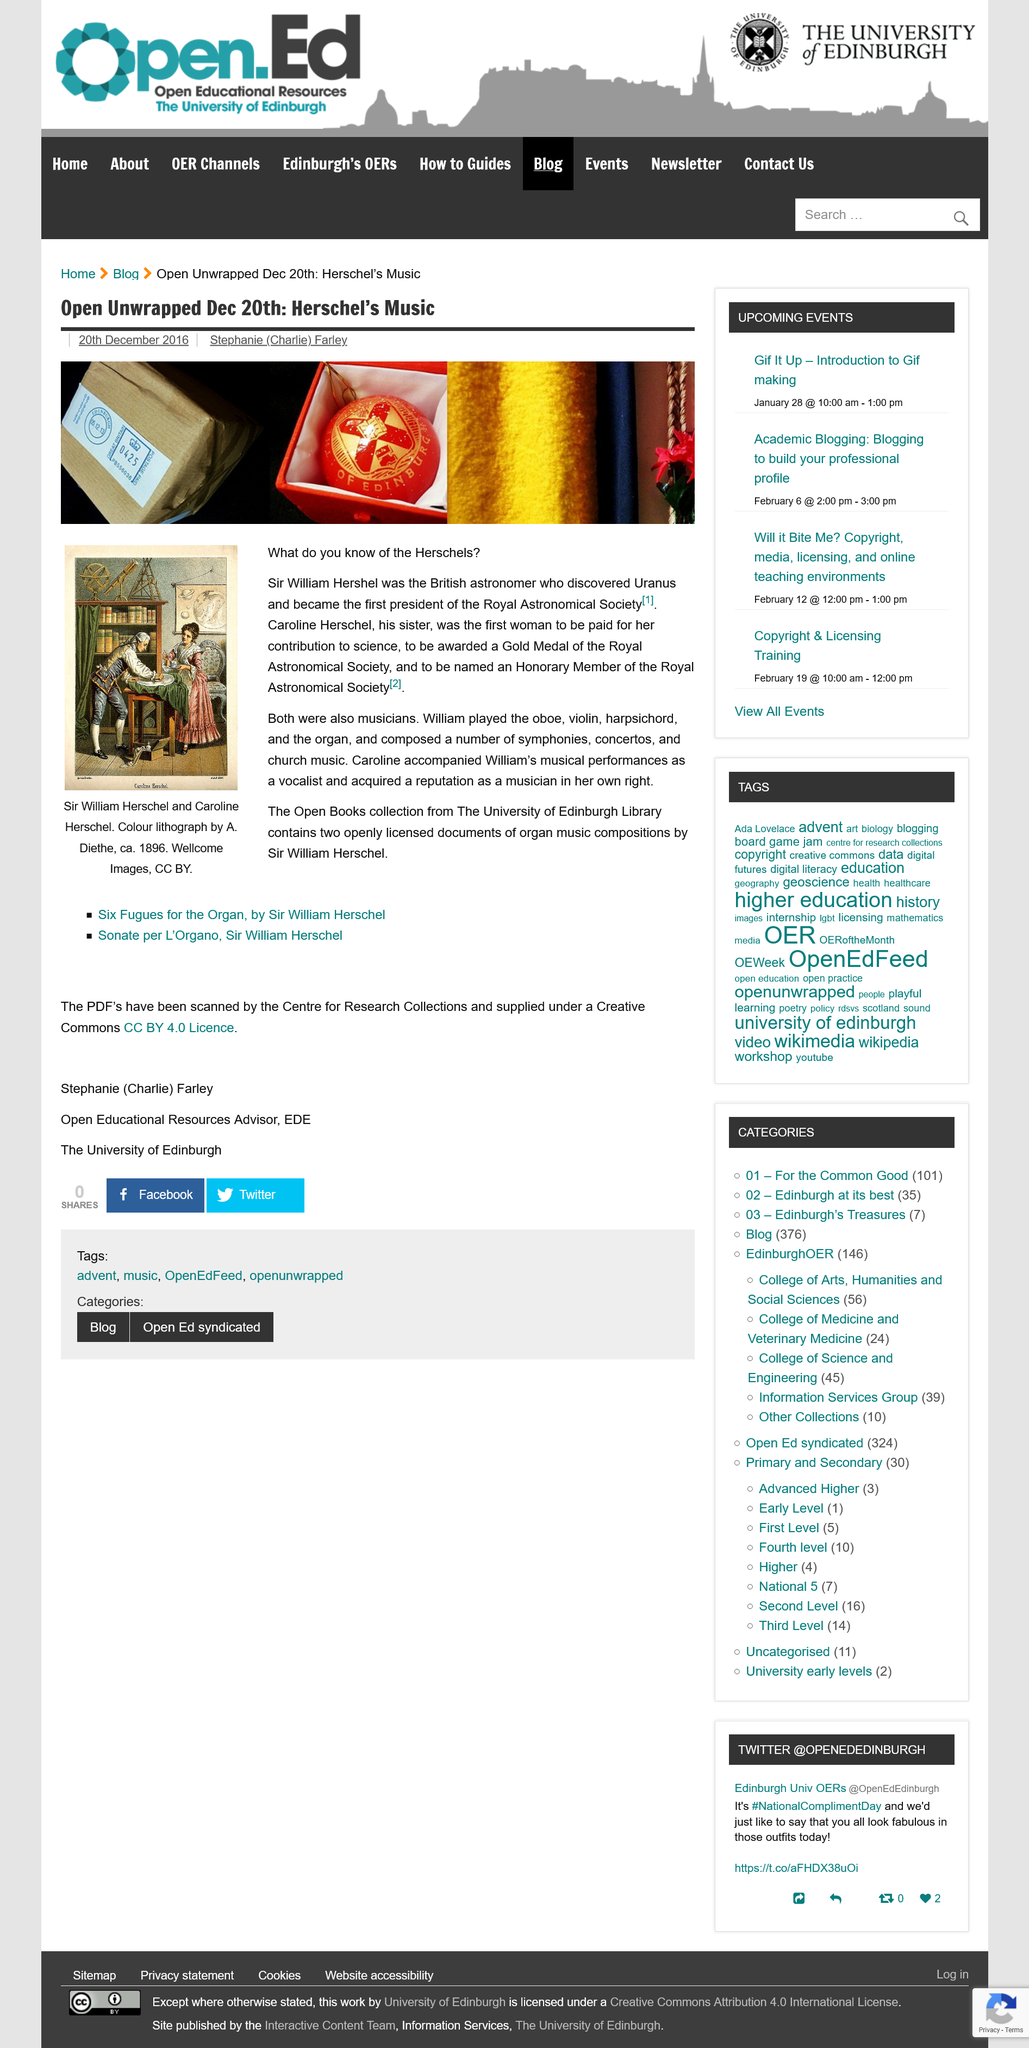Mention a couple of crucial points in this snapshot. Sir William Herschel played the oboe, violin, harpsichord, and organ. Sir William Hershel discovered Uranus, the seventh planet from the sun in our solar system. The Royal Astronomical Society was founded by Sir William Herschel, who served as its first president. 